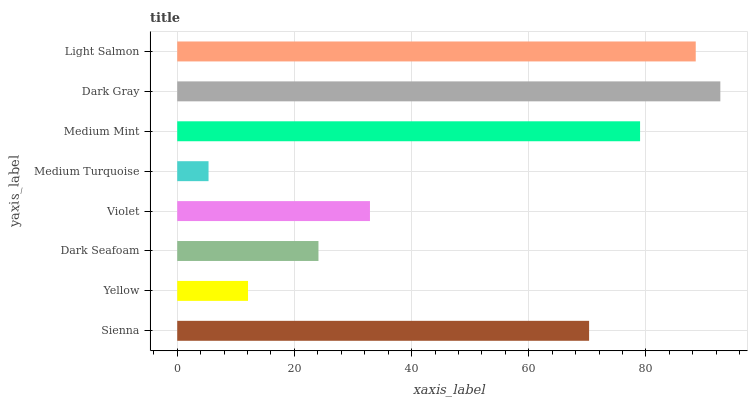Is Medium Turquoise the minimum?
Answer yes or no. Yes. Is Dark Gray the maximum?
Answer yes or no. Yes. Is Yellow the minimum?
Answer yes or no. No. Is Yellow the maximum?
Answer yes or no. No. Is Sienna greater than Yellow?
Answer yes or no. Yes. Is Yellow less than Sienna?
Answer yes or no. Yes. Is Yellow greater than Sienna?
Answer yes or no. No. Is Sienna less than Yellow?
Answer yes or no. No. Is Sienna the high median?
Answer yes or no. Yes. Is Violet the low median?
Answer yes or no. Yes. Is Medium Turquoise the high median?
Answer yes or no. No. Is Medium Turquoise the low median?
Answer yes or no. No. 